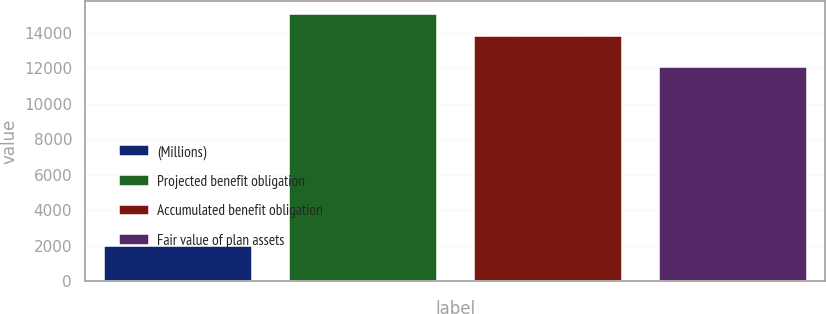<chart> <loc_0><loc_0><loc_500><loc_500><bar_chart><fcel>(Millions)<fcel>Projected benefit obligation<fcel>Accumulated benefit obligation<fcel>Fair value of plan assets<nl><fcel>2011<fcel>15052.8<fcel>13804<fcel>12102<nl></chart> 